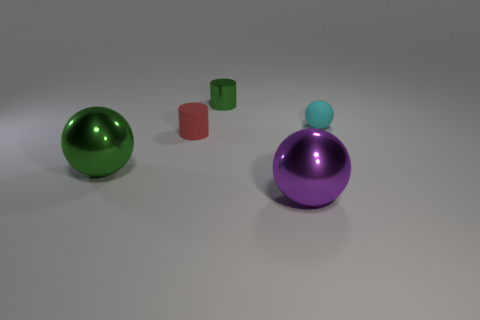Add 4 rubber spheres. How many objects exist? 9 Subtract all cylinders. How many objects are left? 3 Add 4 large green shiny balls. How many large green shiny balls exist? 5 Subtract 0 red cubes. How many objects are left? 5 Subtract all gray cylinders. Subtract all big green balls. How many objects are left? 4 Add 2 red rubber cylinders. How many red rubber cylinders are left? 3 